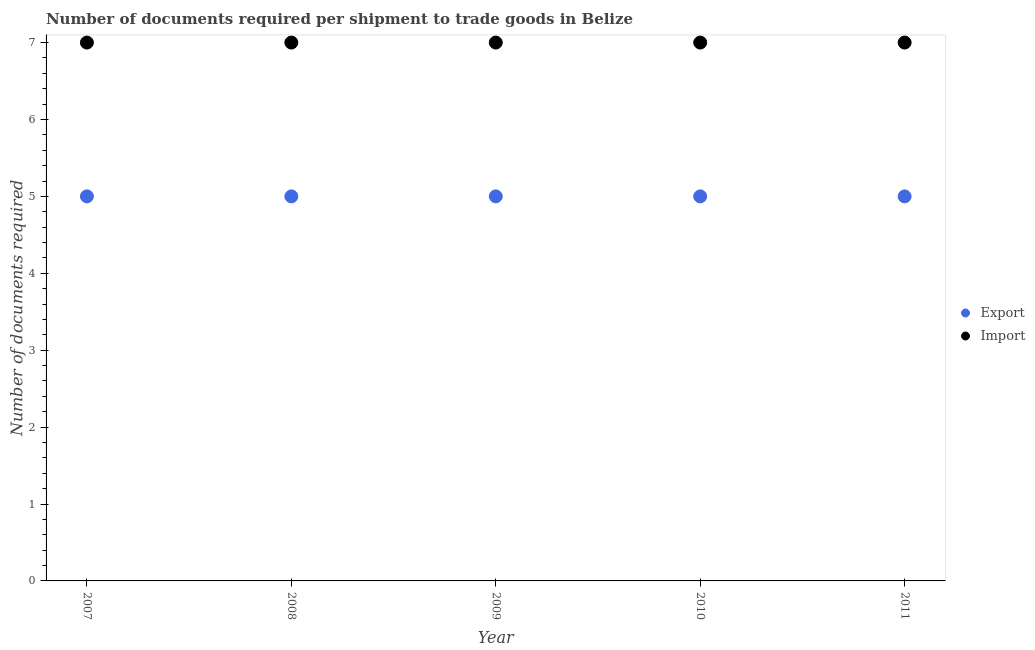What is the number of documents required to import goods in 2009?
Offer a very short reply. 7. Across all years, what is the maximum number of documents required to import goods?
Provide a short and direct response. 7. Across all years, what is the minimum number of documents required to export goods?
Your response must be concise. 5. In which year was the number of documents required to export goods maximum?
Offer a very short reply. 2007. What is the total number of documents required to import goods in the graph?
Provide a succinct answer. 35. What is the difference between the number of documents required to import goods in 2007 and that in 2008?
Provide a short and direct response. 0. What is the difference between the number of documents required to export goods in 2007 and the number of documents required to import goods in 2009?
Your answer should be very brief. -2. What is the average number of documents required to export goods per year?
Keep it short and to the point. 5. In the year 2008, what is the difference between the number of documents required to import goods and number of documents required to export goods?
Keep it short and to the point. 2. In how many years, is the number of documents required to import goods greater than 3.6?
Offer a very short reply. 5. What is the ratio of the number of documents required to import goods in 2007 to that in 2010?
Your answer should be very brief. 1. Is the number of documents required to import goods in 2007 less than that in 2011?
Your answer should be very brief. No. Is the difference between the number of documents required to import goods in 2008 and 2011 greater than the difference between the number of documents required to export goods in 2008 and 2011?
Offer a terse response. No. In how many years, is the number of documents required to export goods greater than the average number of documents required to export goods taken over all years?
Provide a short and direct response. 0. Is the number of documents required to import goods strictly less than the number of documents required to export goods over the years?
Your answer should be compact. No. How many years are there in the graph?
Give a very brief answer. 5. What is the difference between two consecutive major ticks on the Y-axis?
Your answer should be compact. 1. Are the values on the major ticks of Y-axis written in scientific E-notation?
Your answer should be compact. No. Does the graph contain any zero values?
Offer a very short reply. No. Does the graph contain grids?
Give a very brief answer. No. Where does the legend appear in the graph?
Offer a very short reply. Center right. What is the title of the graph?
Your answer should be compact. Number of documents required per shipment to trade goods in Belize. What is the label or title of the X-axis?
Your response must be concise. Year. What is the label or title of the Y-axis?
Provide a succinct answer. Number of documents required. What is the Number of documents required in Export in 2007?
Your response must be concise. 5. What is the Number of documents required of Import in 2008?
Your answer should be compact. 7. What is the Number of documents required of Export in 2010?
Provide a short and direct response. 5. What is the Number of documents required in Import in 2010?
Your answer should be very brief. 7. Across all years, what is the maximum Number of documents required in Import?
Make the answer very short. 7. Across all years, what is the minimum Number of documents required of Import?
Provide a short and direct response. 7. What is the total Number of documents required in Export in the graph?
Offer a terse response. 25. What is the difference between the Number of documents required of Export in 2007 and that in 2008?
Your answer should be very brief. 0. What is the difference between the Number of documents required in Import in 2007 and that in 2008?
Provide a short and direct response. 0. What is the difference between the Number of documents required of Export in 2007 and that in 2009?
Give a very brief answer. 0. What is the difference between the Number of documents required of Import in 2007 and that in 2009?
Your answer should be very brief. 0. What is the difference between the Number of documents required in Export in 2007 and that in 2011?
Provide a short and direct response. 0. What is the difference between the Number of documents required of Import in 2007 and that in 2011?
Your answer should be compact. 0. What is the difference between the Number of documents required of Import in 2008 and that in 2009?
Make the answer very short. 0. What is the difference between the Number of documents required of Export in 2008 and that in 2010?
Your answer should be compact. 0. What is the difference between the Number of documents required in Import in 2008 and that in 2010?
Offer a terse response. 0. What is the difference between the Number of documents required of Export in 2008 and that in 2011?
Ensure brevity in your answer.  0. What is the difference between the Number of documents required of Export in 2009 and that in 2010?
Your answer should be compact. 0. What is the difference between the Number of documents required in Import in 2009 and that in 2010?
Keep it short and to the point. 0. What is the difference between the Number of documents required of Import in 2009 and that in 2011?
Your response must be concise. 0. What is the difference between the Number of documents required of Export in 2010 and that in 2011?
Give a very brief answer. 0. What is the difference between the Number of documents required in Export in 2007 and the Number of documents required in Import in 2010?
Ensure brevity in your answer.  -2. What is the difference between the Number of documents required of Export in 2007 and the Number of documents required of Import in 2011?
Offer a very short reply. -2. What is the difference between the Number of documents required in Export in 2008 and the Number of documents required in Import in 2011?
Ensure brevity in your answer.  -2. What is the difference between the Number of documents required in Export in 2009 and the Number of documents required in Import in 2011?
Provide a short and direct response. -2. What is the average Number of documents required of Export per year?
Give a very brief answer. 5. What is the average Number of documents required in Import per year?
Provide a short and direct response. 7. In the year 2009, what is the difference between the Number of documents required in Export and Number of documents required in Import?
Ensure brevity in your answer.  -2. In the year 2011, what is the difference between the Number of documents required of Export and Number of documents required of Import?
Give a very brief answer. -2. What is the ratio of the Number of documents required of Import in 2007 to that in 2008?
Your response must be concise. 1. What is the ratio of the Number of documents required in Export in 2007 to that in 2009?
Offer a terse response. 1. What is the ratio of the Number of documents required of Import in 2007 to that in 2009?
Offer a very short reply. 1. What is the ratio of the Number of documents required in Export in 2007 to that in 2011?
Keep it short and to the point. 1. What is the ratio of the Number of documents required in Export in 2008 to that in 2009?
Provide a short and direct response. 1. What is the ratio of the Number of documents required of Export in 2008 to that in 2011?
Ensure brevity in your answer.  1. What is the ratio of the Number of documents required in Import in 2008 to that in 2011?
Offer a very short reply. 1. What is the ratio of the Number of documents required in Import in 2010 to that in 2011?
Ensure brevity in your answer.  1. What is the difference between the highest and the lowest Number of documents required of Import?
Your answer should be compact. 0. 